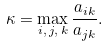Convert formula to latex. <formula><loc_0><loc_0><loc_500><loc_500>\kappa = \max _ { i , \, j , \, k } \frac { a _ { i k } } { a _ { j k } } .</formula> 